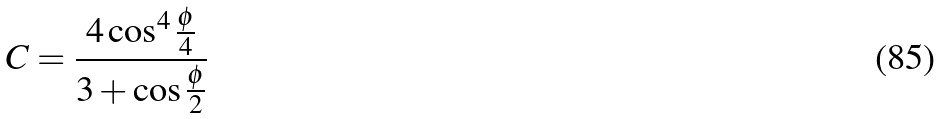Convert formula to latex. <formula><loc_0><loc_0><loc_500><loc_500>C = \frac { 4 \cos ^ { 4 } { \frac { \phi } { 4 } } } { 3 + \cos \frac { \phi } { 2 } }</formula> 